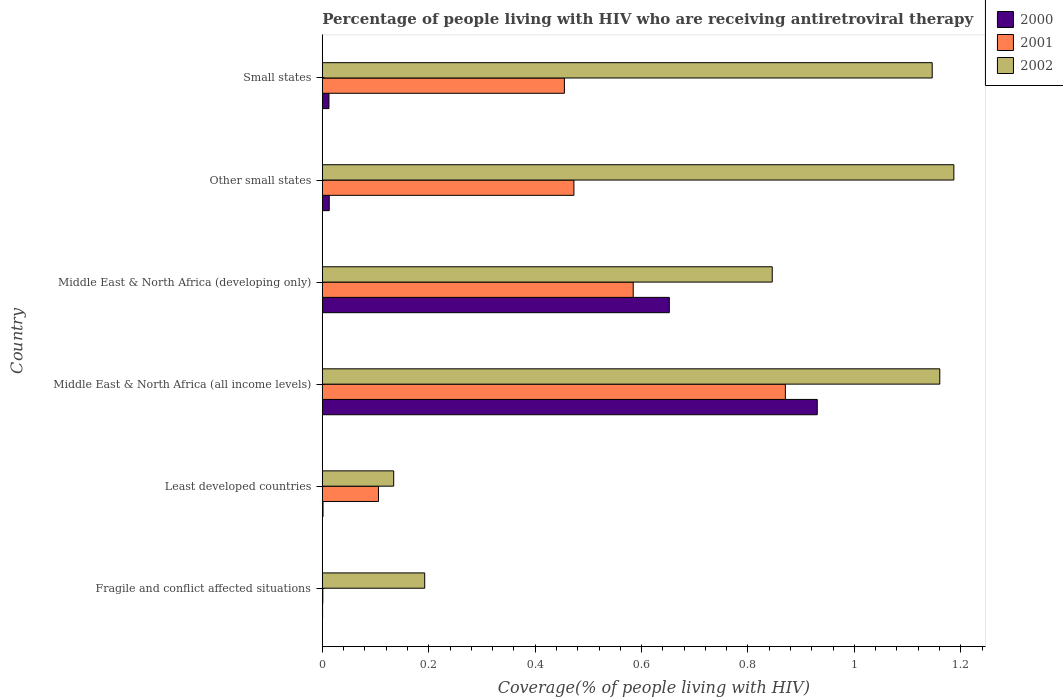How many different coloured bars are there?
Ensure brevity in your answer.  3. Are the number of bars per tick equal to the number of legend labels?
Provide a succinct answer. Yes. What is the label of the 2nd group of bars from the top?
Your answer should be compact. Other small states. In how many cases, is the number of bars for a given country not equal to the number of legend labels?
Your response must be concise. 0. What is the percentage of the HIV infected people who are receiving antiretroviral therapy in 2000 in Small states?
Keep it short and to the point. 0.01. Across all countries, what is the maximum percentage of the HIV infected people who are receiving antiretroviral therapy in 2000?
Give a very brief answer. 0.93. Across all countries, what is the minimum percentage of the HIV infected people who are receiving antiretroviral therapy in 2002?
Provide a short and direct response. 0.13. In which country was the percentage of the HIV infected people who are receiving antiretroviral therapy in 2000 maximum?
Keep it short and to the point. Middle East & North Africa (all income levels). In which country was the percentage of the HIV infected people who are receiving antiretroviral therapy in 2000 minimum?
Provide a succinct answer. Fragile and conflict affected situations. What is the total percentage of the HIV infected people who are receiving antiretroviral therapy in 2000 in the graph?
Provide a succinct answer. 1.61. What is the difference between the percentage of the HIV infected people who are receiving antiretroviral therapy in 2002 in Middle East & North Africa (all income levels) and that in Other small states?
Give a very brief answer. -0.03. What is the difference between the percentage of the HIV infected people who are receiving antiretroviral therapy in 2001 in Middle East & North Africa (developing only) and the percentage of the HIV infected people who are receiving antiretroviral therapy in 2000 in Least developed countries?
Provide a succinct answer. 0.58. What is the average percentage of the HIV infected people who are receiving antiretroviral therapy in 2000 per country?
Provide a short and direct response. 0.27. What is the difference between the percentage of the HIV infected people who are receiving antiretroviral therapy in 2001 and percentage of the HIV infected people who are receiving antiretroviral therapy in 2002 in Least developed countries?
Your response must be concise. -0.03. In how many countries, is the percentage of the HIV infected people who are receiving antiretroviral therapy in 2001 greater than 1.04 %?
Give a very brief answer. 0. What is the ratio of the percentage of the HIV infected people who are receiving antiretroviral therapy in 2002 in Middle East & North Africa (developing only) to that in Small states?
Provide a succinct answer. 0.74. Is the percentage of the HIV infected people who are receiving antiretroviral therapy in 2002 in Middle East & North Africa (all income levels) less than that in Other small states?
Ensure brevity in your answer.  Yes. What is the difference between the highest and the second highest percentage of the HIV infected people who are receiving antiretroviral therapy in 2000?
Provide a succinct answer. 0.28. What is the difference between the highest and the lowest percentage of the HIV infected people who are receiving antiretroviral therapy in 2000?
Your answer should be compact. 0.93. Is the sum of the percentage of the HIV infected people who are receiving antiretroviral therapy in 2000 in Fragile and conflict affected situations and Middle East & North Africa (all income levels) greater than the maximum percentage of the HIV infected people who are receiving antiretroviral therapy in 2002 across all countries?
Your answer should be compact. No. What does the 1st bar from the top in Fragile and conflict affected situations represents?
Your response must be concise. 2002. Is it the case that in every country, the sum of the percentage of the HIV infected people who are receiving antiretroviral therapy in 2002 and percentage of the HIV infected people who are receiving antiretroviral therapy in 2001 is greater than the percentage of the HIV infected people who are receiving antiretroviral therapy in 2000?
Offer a very short reply. Yes. How many bars are there?
Provide a short and direct response. 18. Are all the bars in the graph horizontal?
Offer a terse response. Yes. Are the values on the major ticks of X-axis written in scientific E-notation?
Offer a terse response. No. Does the graph contain any zero values?
Provide a short and direct response. No. Where does the legend appear in the graph?
Keep it short and to the point. Top right. How many legend labels are there?
Give a very brief answer. 3. How are the legend labels stacked?
Give a very brief answer. Vertical. What is the title of the graph?
Your answer should be very brief. Percentage of people living with HIV who are receiving antiretroviral therapy. Does "2008" appear as one of the legend labels in the graph?
Make the answer very short. No. What is the label or title of the X-axis?
Keep it short and to the point. Coverage(% of people living with HIV). What is the Coverage(% of people living with HIV) in 2000 in Fragile and conflict affected situations?
Make the answer very short. 0. What is the Coverage(% of people living with HIV) of 2001 in Fragile and conflict affected situations?
Provide a short and direct response. 0. What is the Coverage(% of people living with HIV) in 2002 in Fragile and conflict affected situations?
Your answer should be compact. 0.19. What is the Coverage(% of people living with HIV) of 2000 in Least developed countries?
Give a very brief answer. 0. What is the Coverage(% of people living with HIV) in 2001 in Least developed countries?
Your response must be concise. 0.11. What is the Coverage(% of people living with HIV) in 2002 in Least developed countries?
Provide a succinct answer. 0.13. What is the Coverage(% of people living with HIV) of 2000 in Middle East & North Africa (all income levels)?
Give a very brief answer. 0.93. What is the Coverage(% of people living with HIV) in 2001 in Middle East & North Africa (all income levels)?
Provide a succinct answer. 0.87. What is the Coverage(% of people living with HIV) in 2002 in Middle East & North Africa (all income levels)?
Offer a very short reply. 1.16. What is the Coverage(% of people living with HIV) in 2000 in Middle East & North Africa (developing only)?
Provide a succinct answer. 0.65. What is the Coverage(% of people living with HIV) in 2001 in Middle East & North Africa (developing only)?
Make the answer very short. 0.58. What is the Coverage(% of people living with HIV) in 2002 in Middle East & North Africa (developing only)?
Keep it short and to the point. 0.85. What is the Coverage(% of people living with HIV) in 2000 in Other small states?
Your answer should be very brief. 0.01. What is the Coverage(% of people living with HIV) of 2001 in Other small states?
Offer a terse response. 0.47. What is the Coverage(% of people living with HIV) in 2002 in Other small states?
Make the answer very short. 1.19. What is the Coverage(% of people living with HIV) in 2000 in Small states?
Make the answer very short. 0.01. What is the Coverage(% of people living with HIV) in 2001 in Small states?
Offer a very short reply. 0.45. What is the Coverage(% of people living with HIV) in 2002 in Small states?
Make the answer very short. 1.15. Across all countries, what is the maximum Coverage(% of people living with HIV) of 2000?
Provide a short and direct response. 0.93. Across all countries, what is the maximum Coverage(% of people living with HIV) of 2001?
Your response must be concise. 0.87. Across all countries, what is the maximum Coverage(% of people living with HIV) in 2002?
Make the answer very short. 1.19. Across all countries, what is the minimum Coverage(% of people living with HIV) of 2000?
Keep it short and to the point. 0. Across all countries, what is the minimum Coverage(% of people living with HIV) in 2001?
Offer a terse response. 0. Across all countries, what is the minimum Coverage(% of people living with HIV) of 2002?
Give a very brief answer. 0.13. What is the total Coverage(% of people living with HIV) in 2000 in the graph?
Offer a terse response. 1.61. What is the total Coverage(% of people living with HIV) of 2001 in the graph?
Ensure brevity in your answer.  2.49. What is the total Coverage(% of people living with HIV) of 2002 in the graph?
Offer a terse response. 4.67. What is the difference between the Coverage(% of people living with HIV) in 2000 in Fragile and conflict affected situations and that in Least developed countries?
Your response must be concise. -0. What is the difference between the Coverage(% of people living with HIV) of 2001 in Fragile and conflict affected situations and that in Least developed countries?
Offer a terse response. -0.1. What is the difference between the Coverage(% of people living with HIV) of 2002 in Fragile and conflict affected situations and that in Least developed countries?
Offer a terse response. 0.06. What is the difference between the Coverage(% of people living with HIV) in 2000 in Fragile and conflict affected situations and that in Middle East & North Africa (all income levels)?
Your answer should be very brief. -0.93. What is the difference between the Coverage(% of people living with HIV) of 2001 in Fragile and conflict affected situations and that in Middle East & North Africa (all income levels)?
Make the answer very short. -0.87. What is the difference between the Coverage(% of people living with HIV) of 2002 in Fragile and conflict affected situations and that in Middle East & North Africa (all income levels)?
Provide a short and direct response. -0.97. What is the difference between the Coverage(% of people living with HIV) in 2000 in Fragile and conflict affected situations and that in Middle East & North Africa (developing only)?
Give a very brief answer. -0.65. What is the difference between the Coverage(% of people living with HIV) in 2001 in Fragile and conflict affected situations and that in Middle East & North Africa (developing only)?
Offer a terse response. -0.58. What is the difference between the Coverage(% of people living with HIV) in 2002 in Fragile and conflict affected situations and that in Middle East & North Africa (developing only)?
Your response must be concise. -0.65. What is the difference between the Coverage(% of people living with HIV) of 2000 in Fragile and conflict affected situations and that in Other small states?
Ensure brevity in your answer.  -0.01. What is the difference between the Coverage(% of people living with HIV) of 2001 in Fragile and conflict affected situations and that in Other small states?
Keep it short and to the point. -0.47. What is the difference between the Coverage(% of people living with HIV) in 2002 in Fragile and conflict affected situations and that in Other small states?
Offer a very short reply. -0.99. What is the difference between the Coverage(% of people living with HIV) of 2000 in Fragile and conflict affected situations and that in Small states?
Make the answer very short. -0.01. What is the difference between the Coverage(% of people living with HIV) of 2001 in Fragile and conflict affected situations and that in Small states?
Offer a very short reply. -0.45. What is the difference between the Coverage(% of people living with HIV) of 2002 in Fragile and conflict affected situations and that in Small states?
Keep it short and to the point. -0.95. What is the difference between the Coverage(% of people living with HIV) in 2000 in Least developed countries and that in Middle East & North Africa (all income levels)?
Keep it short and to the point. -0.93. What is the difference between the Coverage(% of people living with HIV) in 2001 in Least developed countries and that in Middle East & North Africa (all income levels)?
Your answer should be very brief. -0.76. What is the difference between the Coverage(% of people living with HIV) in 2002 in Least developed countries and that in Middle East & North Africa (all income levels)?
Offer a terse response. -1.03. What is the difference between the Coverage(% of people living with HIV) of 2000 in Least developed countries and that in Middle East & North Africa (developing only)?
Provide a succinct answer. -0.65. What is the difference between the Coverage(% of people living with HIV) of 2001 in Least developed countries and that in Middle East & North Africa (developing only)?
Offer a very short reply. -0.48. What is the difference between the Coverage(% of people living with HIV) of 2002 in Least developed countries and that in Middle East & North Africa (developing only)?
Your answer should be very brief. -0.71. What is the difference between the Coverage(% of people living with HIV) of 2000 in Least developed countries and that in Other small states?
Your answer should be compact. -0.01. What is the difference between the Coverage(% of people living with HIV) of 2001 in Least developed countries and that in Other small states?
Your answer should be compact. -0.37. What is the difference between the Coverage(% of people living with HIV) in 2002 in Least developed countries and that in Other small states?
Offer a terse response. -1.05. What is the difference between the Coverage(% of people living with HIV) in 2000 in Least developed countries and that in Small states?
Provide a short and direct response. -0.01. What is the difference between the Coverage(% of people living with HIV) of 2001 in Least developed countries and that in Small states?
Your answer should be very brief. -0.35. What is the difference between the Coverage(% of people living with HIV) of 2002 in Least developed countries and that in Small states?
Give a very brief answer. -1.01. What is the difference between the Coverage(% of people living with HIV) in 2000 in Middle East & North Africa (all income levels) and that in Middle East & North Africa (developing only)?
Give a very brief answer. 0.28. What is the difference between the Coverage(% of people living with HIV) of 2001 in Middle East & North Africa (all income levels) and that in Middle East & North Africa (developing only)?
Your answer should be compact. 0.29. What is the difference between the Coverage(% of people living with HIV) of 2002 in Middle East & North Africa (all income levels) and that in Middle East & North Africa (developing only)?
Offer a terse response. 0.31. What is the difference between the Coverage(% of people living with HIV) in 2000 in Middle East & North Africa (all income levels) and that in Other small states?
Give a very brief answer. 0.92. What is the difference between the Coverage(% of people living with HIV) of 2001 in Middle East & North Africa (all income levels) and that in Other small states?
Offer a terse response. 0.4. What is the difference between the Coverage(% of people living with HIV) in 2002 in Middle East & North Africa (all income levels) and that in Other small states?
Offer a terse response. -0.03. What is the difference between the Coverage(% of people living with HIV) in 2000 in Middle East & North Africa (all income levels) and that in Small states?
Give a very brief answer. 0.92. What is the difference between the Coverage(% of people living with HIV) of 2001 in Middle East & North Africa (all income levels) and that in Small states?
Give a very brief answer. 0.42. What is the difference between the Coverage(% of people living with HIV) in 2002 in Middle East & North Africa (all income levels) and that in Small states?
Ensure brevity in your answer.  0.01. What is the difference between the Coverage(% of people living with HIV) of 2000 in Middle East & North Africa (developing only) and that in Other small states?
Make the answer very short. 0.64. What is the difference between the Coverage(% of people living with HIV) of 2001 in Middle East & North Africa (developing only) and that in Other small states?
Provide a succinct answer. 0.11. What is the difference between the Coverage(% of people living with HIV) in 2002 in Middle East & North Africa (developing only) and that in Other small states?
Ensure brevity in your answer.  -0.34. What is the difference between the Coverage(% of people living with HIV) of 2000 in Middle East & North Africa (developing only) and that in Small states?
Your answer should be very brief. 0.64. What is the difference between the Coverage(% of people living with HIV) in 2001 in Middle East & North Africa (developing only) and that in Small states?
Ensure brevity in your answer.  0.13. What is the difference between the Coverage(% of people living with HIV) in 2002 in Middle East & North Africa (developing only) and that in Small states?
Ensure brevity in your answer.  -0.3. What is the difference between the Coverage(% of people living with HIV) of 2000 in Other small states and that in Small states?
Your response must be concise. 0. What is the difference between the Coverage(% of people living with HIV) of 2001 in Other small states and that in Small states?
Offer a very short reply. 0.02. What is the difference between the Coverage(% of people living with HIV) in 2002 in Other small states and that in Small states?
Make the answer very short. 0.04. What is the difference between the Coverage(% of people living with HIV) in 2000 in Fragile and conflict affected situations and the Coverage(% of people living with HIV) in 2001 in Least developed countries?
Give a very brief answer. -0.1. What is the difference between the Coverage(% of people living with HIV) of 2000 in Fragile and conflict affected situations and the Coverage(% of people living with HIV) of 2002 in Least developed countries?
Offer a very short reply. -0.13. What is the difference between the Coverage(% of people living with HIV) in 2001 in Fragile and conflict affected situations and the Coverage(% of people living with HIV) in 2002 in Least developed countries?
Your answer should be very brief. -0.13. What is the difference between the Coverage(% of people living with HIV) in 2000 in Fragile and conflict affected situations and the Coverage(% of people living with HIV) in 2001 in Middle East & North Africa (all income levels)?
Ensure brevity in your answer.  -0.87. What is the difference between the Coverage(% of people living with HIV) in 2000 in Fragile and conflict affected situations and the Coverage(% of people living with HIV) in 2002 in Middle East & North Africa (all income levels)?
Give a very brief answer. -1.16. What is the difference between the Coverage(% of people living with HIV) in 2001 in Fragile and conflict affected situations and the Coverage(% of people living with HIV) in 2002 in Middle East & North Africa (all income levels)?
Your answer should be compact. -1.16. What is the difference between the Coverage(% of people living with HIV) in 2000 in Fragile and conflict affected situations and the Coverage(% of people living with HIV) in 2001 in Middle East & North Africa (developing only)?
Your response must be concise. -0.58. What is the difference between the Coverage(% of people living with HIV) of 2000 in Fragile and conflict affected situations and the Coverage(% of people living with HIV) of 2002 in Middle East & North Africa (developing only)?
Offer a very short reply. -0.85. What is the difference between the Coverage(% of people living with HIV) in 2001 in Fragile and conflict affected situations and the Coverage(% of people living with HIV) in 2002 in Middle East & North Africa (developing only)?
Provide a succinct answer. -0.84. What is the difference between the Coverage(% of people living with HIV) of 2000 in Fragile and conflict affected situations and the Coverage(% of people living with HIV) of 2001 in Other small states?
Provide a short and direct response. -0.47. What is the difference between the Coverage(% of people living with HIV) of 2000 in Fragile and conflict affected situations and the Coverage(% of people living with HIV) of 2002 in Other small states?
Give a very brief answer. -1.19. What is the difference between the Coverage(% of people living with HIV) in 2001 in Fragile and conflict affected situations and the Coverage(% of people living with HIV) in 2002 in Other small states?
Keep it short and to the point. -1.19. What is the difference between the Coverage(% of people living with HIV) of 2000 in Fragile and conflict affected situations and the Coverage(% of people living with HIV) of 2001 in Small states?
Keep it short and to the point. -0.45. What is the difference between the Coverage(% of people living with HIV) in 2000 in Fragile and conflict affected situations and the Coverage(% of people living with HIV) in 2002 in Small states?
Provide a short and direct response. -1.15. What is the difference between the Coverage(% of people living with HIV) in 2001 in Fragile and conflict affected situations and the Coverage(% of people living with HIV) in 2002 in Small states?
Make the answer very short. -1.15. What is the difference between the Coverage(% of people living with HIV) of 2000 in Least developed countries and the Coverage(% of people living with HIV) of 2001 in Middle East & North Africa (all income levels)?
Your answer should be very brief. -0.87. What is the difference between the Coverage(% of people living with HIV) of 2000 in Least developed countries and the Coverage(% of people living with HIV) of 2002 in Middle East & North Africa (all income levels)?
Ensure brevity in your answer.  -1.16. What is the difference between the Coverage(% of people living with HIV) in 2001 in Least developed countries and the Coverage(% of people living with HIV) in 2002 in Middle East & North Africa (all income levels)?
Your answer should be compact. -1.05. What is the difference between the Coverage(% of people living with HIV) in 2000 in Least developed countries and the Coverage(% of people living with HIV) in 2001 in Middle East & North Africa (developing only)?
Provide a succinct answer. -0.58. What is the difference between the Coverage(% of people living with HIV) in 2000 in Least developed countries and the Coverage(% of people living with HIV) in 2002 in Middle East & North Africa (developing only)?
Your answer should be compact. -0.84. What is the difference between the Coverage(% of people living with HIV) in 2001 in Least developed countries and the Coverage(% of people living with HIV) in 2002 in Middle East & North Africa (developing only)?
Make the answer very short. -0.74. What is the difference between the Coverage(% of people living with HIV) in 2000 in Least developed countries and the Coverage(% of people living with HIV) in 2001 in Other small states?
Provide a short and direct response. -0.47. What is the difference between the Coverage(% of people living with HIV) of 2000 in Least developed countries and the Coverage(% of people living with HIV) of 2002 in Other small states?
Give a very brief answer. -1.19. What is the difference between the Coverage(% of people living with HIV) in 2001 in Least developed countries and the Coverage(% of people living with HIV) in 2002 in Other small states?
Provide a succinct answer. -1.08. What is the difference between the Coverage(% of people living with HIV) of 2000 in Least developed countries and the Coverage(% of people living with HIV) of 2001 in Small states?
Give a very brief answer. -0.45. What is the difference between the Coverage(% of people living with HIV) in 2000 in Least developed countries and the Coverage(% of people living with HIV) in 2002 in Small states?
Provide a succinct answer. -1.14. What is the difference between the Coverage(% of people living with HIV) of 2001 in Least developed countries and the Coverage(% of people living with HIV) of 2002 in Small states?
Keep it short and to the point. -1.04. What is the difference between the Coverage(% of people living with HIV) of 2000 in Middle East & North Africa (all income levels) and the Coverage(% of people living with HIV) of 2001 in Middle East & North Africa (developing only)?
Your answer should be compact. 0.35. What is the difference between the Coverage(% of people living with HIV) in 2000 in Middle East & North Africa (all income levels) and the Coverage(% of people living with HIV) in 2002 in Middle East & North Africa (developing only)?
Your response must be concise. 0.08. What is the difference between the Coverage(% of people living with HIV) of 2001 in Middle East & North Africa (all income levels) and the Coverage(% of people living with HIV) of 2002 in Middle East & North Africa (developing only)?
Give a very brief answer. 0.02. What is the difference between the Coverage(% of people living with HIV) in 2000 in Middle East & North Africa (all income levels) and the Coverage(% of people living with HIV) in 2001 in Other small states?
Give a very brief answer. 0.46. What is the difference between the Coverage(% of people living with HIV) of 2000 in Middle East & North Africa (all income levels) and the Coverage(% of people living with HIV) of 2002 in Other small states?
Give a very brief answer. -0.26. What is the difference between the Coverage(% of people living with HIV) in 2001 in Middle East & North Africa (all income levels) and the Coverage(% of people living with HIV) in 2002 in Other small states?
Your answer should be compact. -0.32. What is the difference between the Coverage(% of people living with HIV) of 2000 in Middle East & North Africa (all income levels) and the Coverage(% of people living with HIV) of 2001 in Small states?
Offer a very short reply. 0.48. What is the difference between the Coverage(% of people living with HIV) in 2000 in Middle East & North Africa (all income levels) and the Coverage(% of people living with HIV) in 2002 in Small states?
Provide a succinct answer. -0.22. What is the difference between the Coverage(% of people living with HIV) in 2001 in Middle East & North Africa (all income levels) and the Coverage(% of people living with HIV) in 2002 in Small states?
Keep it short and to the point. -0.28. What is the difference between the Coverage(% of people living with HIV) of 2000 in Middle East & North Africa (developing only) and the Coverage(% of people living with HIV) of 2001 in Other small states?
Provide a short and direct response. 0.18. What is the difference between the Coverage(% of people living with HIV) of 2000 in Middle East & North Africa (developing only) and the Coverage(% of people living with HIV) of 2002 in Other small states?
Your response must be concise. -0.53. What is the difference between the Coverage(% of people living with HIV) in 2001 in Middle East & North Africa (developing only) and the Coverage(% of people living with HIV) in 2002 in Other small states?
Make the answer very short. -0.6. What is the difference between the Coverage(% of people living with HIV) of 2000 in Middle East & North Africa (developing only) and the Coverage(% of people living with HIV) of 2001 in Small states?
Provide a succinct answer. 0.2. What is the difference between the Coverage(% of people living with HIV) of 2000 in Middle East & North Africa (developing only) and the Coverage(% of people living with HIV) of 2002 in Small states?
Your response must be concise. -0.49. What is the difference between the Coverage(% of people living with HIV) of 2001 in Middle East & North Africa (developing only) and the Coverage(% of people living with HIV) of 2002 in Small states?
Ensure brevity in your answer.  -0.56. What is the difference between the Coverage(% of people living with HIV) of 2000 in Other small states and the Coverage(% of people living with HIV) of 2001 in Small states?
Ensure brevity in your answer.  -0.44. What is the difference between the Coverage(% of people living with HIV) in 2000 in Other small states and the Coverage(% of people living with HIV) in 2002 in Small states?
Provide a succinct answer. -1.13. What is the difference between the Coverage(% of people living with HIV) in 2001 in Other small states and the Coverage(% of people living with HIV) in 2002 in Small states?
Your answer should be very brief. -0.67. What is the average Coverage(% of people living with HIV) of 2000 per country?
Ensure brevity in your answer.  0.27. What is the average Coverage(% of people living with HIV) in 2001 per country?
Your response must be concise. 0.41. What is the average Coverage(% of people living with HIV) of 2002 per country?
Provide a short and direct response. 0.78. What is the difference between the Coverage(% of people living with HIV) in 2000 and Coverage(% of people living with HIV) in 2001 in Fragile and conflict affected situations?
Give a very brief answer. -0. What is the difference between the Coverage(% of people living with HIV) in 2000 and Coverage(% of people living with HIV) in 2002 in Fragile and conflict affected situations?
Offer a terse response. -0.19. What is the difference between the Coverage(% of people living with HIV) in 2001 and Coverage(% of people living with HIV) in 2002 in Fragile and conflict affected situations?
Give a very brief answer. -0.19. What is the difference between the Coverage(% of people living with HIV) in 2000 and Coverage(% of people living with HIV) in 2001 in Least developed countries?
Ensure brevity in your answer.  -0.1. What is the difference between the Coverage(% of people living with HIV) in 2000 and Coverage(% of people living with HIV) in 2002 in Least developed countries?
Provide a short and direct response. -0.13. What is the difference between the Coverage(% of people living with HIV) of 2001 and Coverage(% of people living with HIV) of 2002 in Least developed countries?
Provide a short and direct response. -0.03. What is the difference between the Coverage(% of people living with HIV) in 2000 and Coverage(% of people living with HIV) in 2002 in Middle East & North Africa (all income levels)?
Your response must be concise. -0.23. What is the difference between the Coverage(% of people living with HIV) of 2001 and Coverage(% of people living with HIV) of 2002 in Middle East & North Africa (all income levels)?
Offer a very short reply. -0.29. What is the difference between the Coverage(% of people living with HIV) in 2000 and Coverage(% of people living with HIV) in 2001 in Middle East & North Africa (developing only)?
Provide a succinct answer. 0.07. What is the difference between the Coverage(% of people living with HIV) of 2000 and Coverage(% of people living with HIV) of 2002 in Middle East & North Africa (developing only)?
Provide a short and direct response. -0.19. What is the difference between the Coverage(% of people living with HIV) of 2001 and Coverage(% of people living with HIV) of 2002 in Middle East & North Africa (developing only)?
Your answer should be compact. -0.26. What is the difference between the Coverage(% of people living with HIV) in 2000 and Coverage(% of people living with HIV) in 2001 in Other small states?
Your response must be concise. -0.46. What is the difference between the Coverage(% of people living with HIV) in 2000 and Coverage(% of people living with HIV) in 2002 in Other small states?
Provide a short and direct response. -1.17. What is the difference between the Coverage(% of people living with HIV) in 2001 and Coverage(% of people living with HIV) in 2002 in Other small states?
Make the answer very short. -0.71. What is the difference between the Coverage(% of people living with HIV) in 2000 and Coverage(% of people living with HIV) in 2001 in Small states?
Provide a succinct answer. -0.44. What is the difference between the Coverage(% of people living with HIV) in 2000 and Coverage(% of people living with HIV) in 2002 in Small states?
Offer a terse response. -1.13. What is the difference between the Coverage(% of people living with HIV) of 2001 and Coverage(% of people living with HIV) of 2002 in Small states?
Provide a short and direct response. -0.69. What is the ratio of the Coverage(% of people living with HIV) in 2000 in Fragile and conflict affected situations to that in Least developed countries?
Provide a short and direct response. 0.36. What is the ratio of the Coverage(% of people living with HIV) of 2001 in Fragile and conflict affected situations to that in Least developed countries?
Provide a succinct answer. 0.01. What is the ratio of the Coverage(% of people living with HIV) of 2002 in Fragile and conflict affected situations to that in Least developed countries?
Offer a terse response. 1.43. What is the ratio of the Coverage(% of people living with HIV) in 2000 in Fragile and conflict affected situations to that in Middle East & North Africa (all income levels)?
Make the answer very short. 0. What is the ratio of the Coverage(% of people living with HIV) of 2001 in Fragile and conflict affected situations to that in Middle East & North Africa (all income levels)?
Offer a very short reply. 0. What is the ratio of the Coverage(% of people living with HIV) in 2002 in Fragile and conflict affected situations to that in Middle East & North Africa (all income levels)?
Provide a short and direct response. 0.17. What is the ratio of the Coverage(% of people living with HIV) of 2000 in Fragile and conflict affected situations to that in Middle East & North Africa (developing only)?
Provide a short and direct response. 0. What is the ratio of the Coverage(% of people living with HIV) of 2001 in Fragile and conflict affected situations to that in Middle East & North Africa (developing only)?
Provide a short and direct response. 0. What is the ratio of the Coverage(% of people living with HIV) in 2002 in Fragile and conflict affected situations to that in Middle East & North Africa (developing only)?
Keep it short and to the point. 0.23. What is the ratio of the Coverage(% of people living with HIV) in 2000 in Fragile and conflict affected situations to that in Other small states?
Provide a succinct answer. 0.04. What is the ratio of the Coverage(% of people living with HIV) in 2001 in Fragile and conflict affected situations to that in Other small states?
Provide a short and direct response. 0. What is the ratio of the Coverage(% of people living with HIV) in 2002 in Fragile and conflict affected situations to that in Other small states?
Provide a succinct answer. 0.16. What is the ratio of the Coverage(% of people living with HIV) in 2000 in Fragile and conflict affected situations to that in Small states?
Make the answer very short. 0.04. What is the ratio of the Coverage(% of people living with HIV) in 2001 in Fragile and conflict affected situations to that in Small states?
Ensure brevity in your answer.  0. What is the ratio of the Coverage(% of people living with HIV) in 2002 in Fragile and conflict affected situations to that in Small states?
Provide a short and direct response. 0.17. What is the ratio of the Coverage(% of people living with HIV) in 2000 in Least developed countries to that in Middle East & North Africa (all income levels)?
Give a very brief answer. 0. What is the ratio of the Coverage(% of people living with HIV) of 2001 in Least developed countries to that in Middle East & North Africa (all income levels)?
Your answer should be very brief. 0.12. What is the ratio of the Coverage(% of people living with HIV) in 2002 in Least developed countries to that in Middle East & North Africa (all income levels)?
Keep it short and to the point. 0.12. What is the ratio of the Coverage(% of people living with HIV) in 2000 in Least developed countries to that in Middle East & North Africa (developing only)?
Keep it short and to the point. 0. What is the ratio of the Coverage(% of people living with HIV) of 2001 in Least developed countries to that in Middle East & North Africa (developing only)?
Keep it short and to the point. 0.18. What is the ratio of the Coverage(% of people living with HIV) in 2002 in Least developed countries to that in Middle East & North Africa (developing only)?
Your response must be concise. 0.16. What is the ratio of the Coverage(% of people living with HIV) in 2000 in Least developed countries to that in Other small states?
Your answer should be very brief. 0.1. What is the ratio of the Coverage(% of people living with HIV) in 2001 in Least developed countries to that in Other small states?
Give a very brief answer. 0.22. What is the ratio of the Coverage(% of people living with HIV) in 2002 in Least developed countries to that in Other small states?
Keep it short and to the point. 0.11. What is the ratio of the Coverage(% of people living with HIV) in 2000 in Least developed countries to that in Small states?
Your response must be concise. 0.11. What is the ratio of the Coverage(% of people living with HIV) in 2001 in Least developed countries to that in Small states?
Give a very brief answer. 0.23. What is the ratio of the Coverage(% of people living with HIV) in 2002 in Least developed countries to that in Small states?
Your answer should be very brief. 0.12. What is the ratio of the Coverage(% of people living with HIV) in 2000 in Middle East & North Africa (all income levels) to that in Middle East & North Africa (developing only)?
Provide a succinct answer. 1.43. What is the ratio of the Coverage(% of people living with HIV) in 2001 in Middle East & North Africa (all income levels) to that in Middle East & North Africa (developing only)?
Your answer should be very brief. 1.49. What is the ratio of the Coverage(% of people living with HIV) in 2002 in Middle East & North Africa (all income levels) to that in Middle East & North Africa (developing only)?
Keep it short and to the point. 1.37. What is the ratio of the Coverage(% of people living with HIV) in 2000 in Middle East & North Africa (all income levels) to that in Other small states?
Give a very brief answer. 71.51. What is the ratio of the Coverage(% of people living with HIV) of 2001 in Middle East & North Africa (all income levels) to that in Other small states?
Your answer should be compact. 1.84. What is the ratio of the Coverage(% of people living with HIV) in 2002 in Middle East & North Africa (all income levels) to that in Other small states?
Provide a succinct answer. 0.98. What is the ratio of the Coverage(% of people living with HIV) in 2000 in Middle East & North Africa (all income levels) to that in Small states?
Keep it short and to the point. 74.75. What is the ratio of the Coverage(% of people living with HIV) in 2001 in Middle East & North Africa (all income levels) to that in Small states?
Your answer should be compact. 1.91. What is the ratio of the Coverage(% of people living with HIV) in 2002 in Middle East & North Africa (all income levels) to that in Small states?
Keep it short and to the point. 1.01. What is the ratio of the Coverage(% of people living with HIV) in 2000 in Middle East & North Africa (developing only) to that in Other small states?
Offer a terse response. 50.14. What is the ratio of the Coverage(% of people living with HIV) in 2001 in Middle East & North Africa (developing only) to that in Other small states?
Offer a very short reply. 1.24. What is the ratio of the Coverage(% of people living with HIV) of 2002 in Middle East & North Africa (developing only) to that in Other small states?
Your response must be concise. 0.71. What is the ratio of the Coverage(% of people living with HIV) in 2000 in Middle East & North Africa (developing only) to that in Small states?
Ensure brevity in your answer.  52.41. What is the ratio of the Coverage(% of people living with HIV) in 2001 in Middle East & North Africa (developing only) to that in Small states?
Provide a succinct answer. 1.28. What is the ratio of the Coverage(% of people living with HIV) in 2002 in Middle East & North Africa (developing only) to that in Small states?
Ensure brevity in your answer.  0.74. What is the ratio of the Coverage(% of people living with HIV) of 2000 in Other small states to that in Small states?
Provide a short and direct response. 1.05. What is the ratio of the Coverage(% of people living with HIV) in 2001 in Other small states to that in Small states?
Provide a succinct answer. 1.04. What is the ratio of the Coverage(% of people living with HIV) of 2002 in Other small states to that in Small states?
Keep it short and to the point. 1.04. What is the difference between the highest and the second highest Coverage(% of people living with HIV) of 2000?
Your answer should be very brief. 0.28. What is the difference between the highest and the second highest Coverage(% of people living with HIV) of 2001?
Ensure brevity in your answer.  0.29. What is the difference between the highest and the second highest Coverage(% of people living with HIV) in 2002?
Ensure brevity in your answer.  0.03. What is the difference between the highest and the lowest Coverage(% of people living with HIV) in 2000?
Provide a succinct answer. 0.93. What is the difference between the highest and the lowest Coverage(% of people living with HIV) of 2001?
Ensure brevity in your answer.  0.87. What is the difference between the highest and the lowest Coverage(% of people living with HIV) in 2002?
Offer a very short reply. 1.05. 